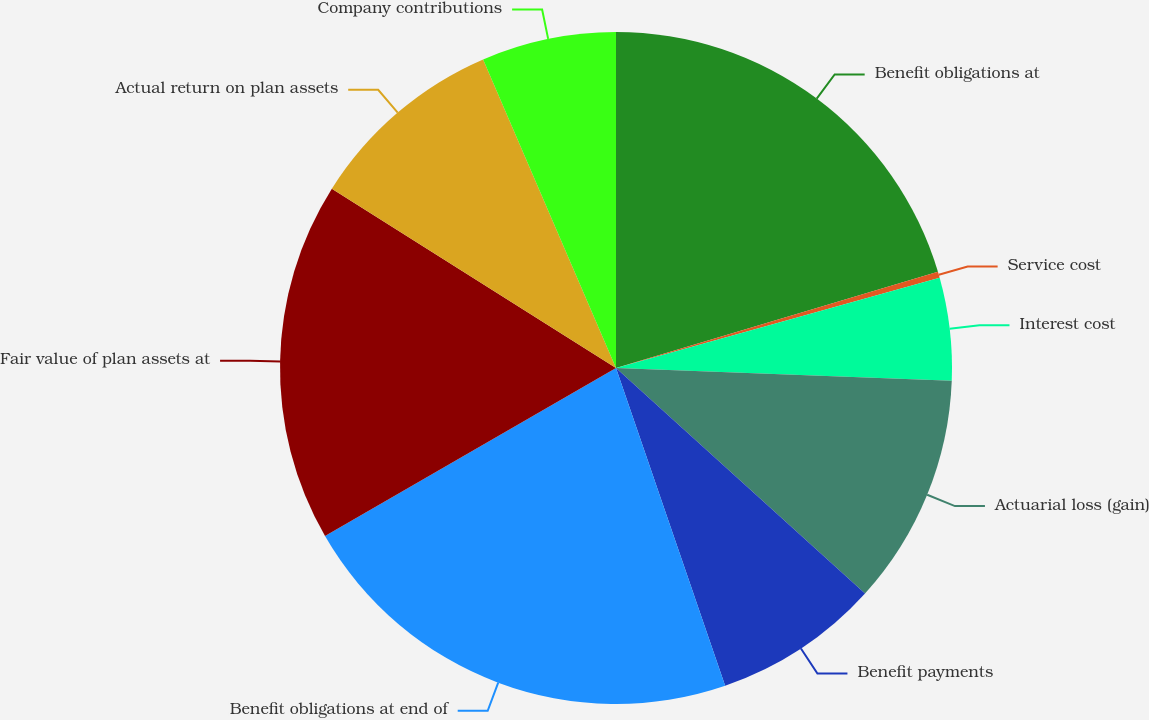Convert chart. <chart><loc_0><loc_0><loc_500><loc_500><pie_chart><fcel>Benefit obligations at<fcel>Service cost<fcel>Interest cost<fcel>Actuarial loss (gain)<fcel>Benefit payments<fcel>Benefit obligations at end of<fcel>Fair value of plan assets at<fcel>Actual return on plan assets<fcel>Company contributions<nl><fcel>20.38%<fcel>0.29%<fcel>4.93%<fcel>11.11%<fcel>8.02%<fcel>21.93%<fcel>17.29%<fcel>9.57%<fcel>6.47%<nl></chart> 